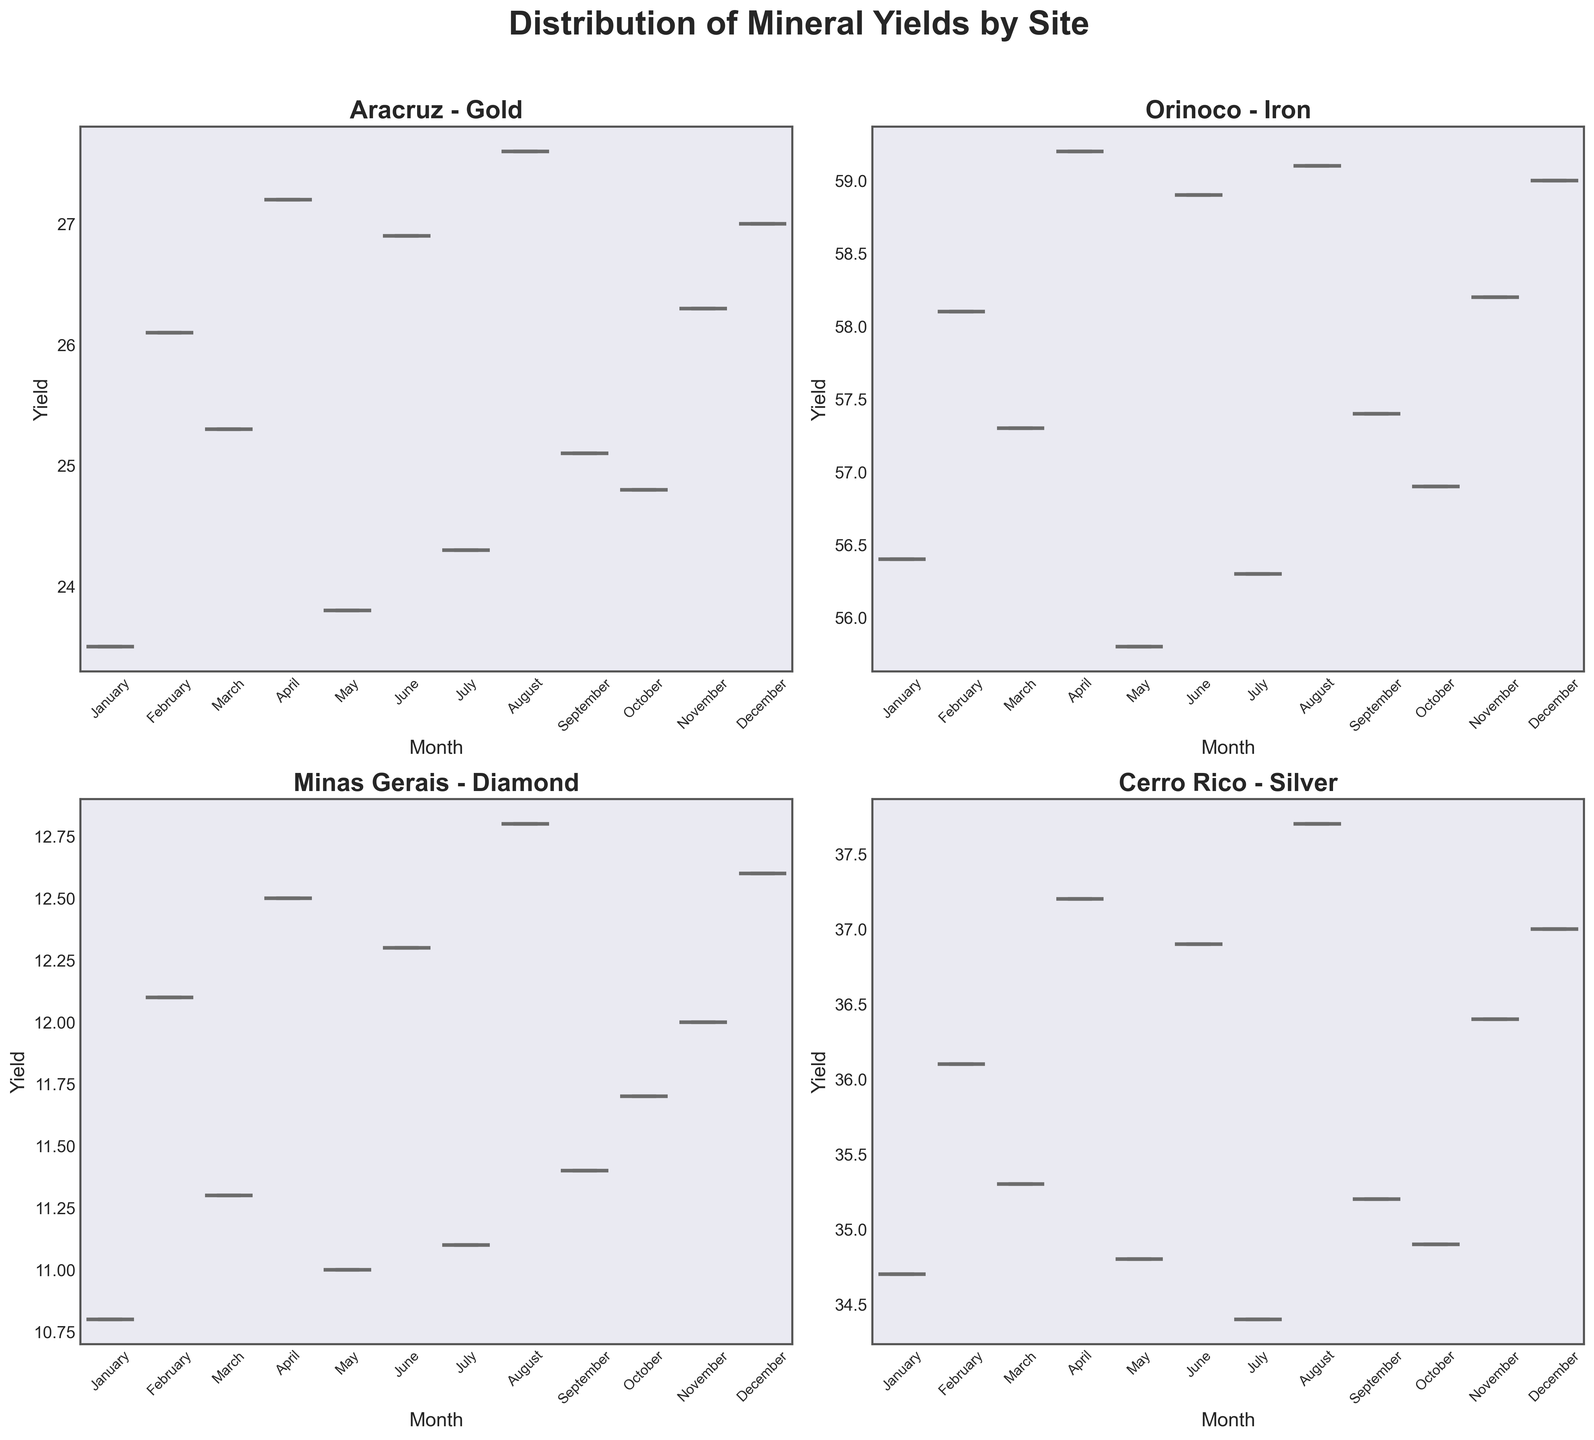What is the title of the figure? The title is prominently displayed at the top of the figure.
Answer: Distribution of Mineral Yields by Site Which mining site shows the highest median yield of minerals? By comparing the central line (median) of each box in the figure, Aracruz appears to have a slightly lower median yield compared to Orinoco and Cerro Rico, and higher than Minas Gerais. But Cerro Rico’s median is the highest.
Answer: Cerro Rico What is the mineral yielded in the Orinoco site? The title of each subplot specifies the mineral yielded at that site.
Answer: Iron Which site has the largest range of mineral yields in any given month? The range of the yields can be determined by comparing the length of the boxes and the whiskers. Orinoco has a larger range in some months compared to the other sites.
Answer: Orinoco During which month does the Aracruz site have the lowest yield of gold? We can determine this by looking for the shortest boxplot height in the Aracruz subplot. The shortest boxplot appears in May.
Answer: May What is the interquartile range of iron yields in the Orinoco site for January? The interquartile range (IQR) can be read off the January box in the Orinoco subplot, which appears substantial. Upon closer inspection, it's from about 56.3 to 58.0.
Answer: 1.7 Which site shows the most consistent yield of minerals over the year? The consistency can be inferred by the number of outliers and the length of the whiskers. Minas Gerais appears to have the shortest whiskers and few outliers, indicating high consistency.
Answer: Minas Gerais Compare the median yields of December across all sites, which one has the lowest median yield? By checking the median lines within the December boxes across all subplots, Minas Gerais has the lowest median yield.
Answer: Minas Gerais Of all the months, in which month does Cerro Rico have the maximum silver yield? The maximum yield in the Cerro Rico subplot can be found by identifying the top whisker or outlier, which is in August.
Answer: August 